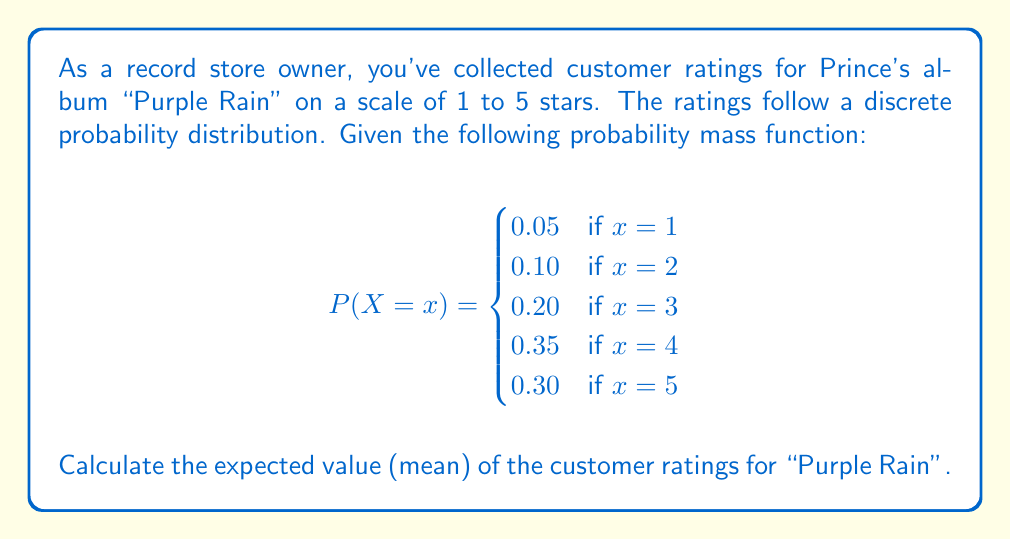Teach me how to tackle this problem. To calculate the expected value (mean) of a discrete random variable, we use the formula:

$$E(X) = \sum_{x} x \cdot P(X = x)$$

Let's calculate this step by step:

1) Multiply each possible value of X by its probability:
   
   For x = 1: $1 \cdot 0.05 = 0.05$
   For x = 2: $2 \cdot 0.10 = 0.20$
   For x = 3: $3 \cdot 0.20 = 0.60$
   For x = 4: $4 \cdot 0.35 = 1.40$
   For x = 5: $5 \cdot 0.30 = 1.50$

2) Sum up all these products:

   $$E(X) = 0.05 + 0.20 + 0.60 + 1.40 + 1.50 = 3.75$$

Therefore, the expected value (mean) of the customer ratings for "Purple Rain" is 3.75 stars.
Answer: 3.75 stars 